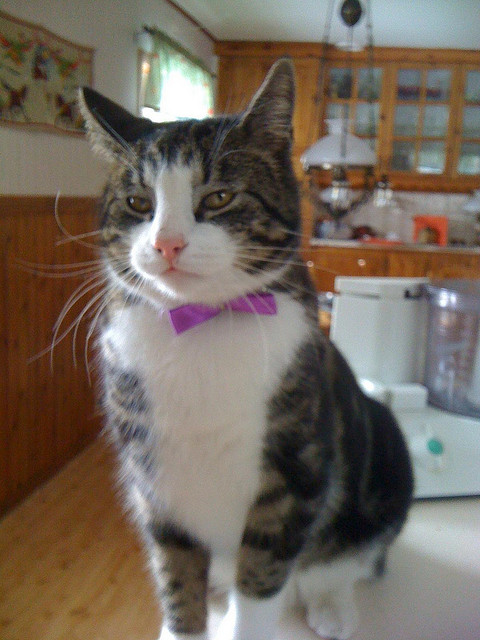<image>What other bigger animal resembles this cat? I don't know which bigger animal resembles this cat. It could be a tiger, cougar, cheetah or lynx. What other bigger animal resembles this cat? I don't know what other bigger animal resembles this cat. It can be seen as a bunny, tiger, cougar, cheetah, lynx or any other similar animal. 